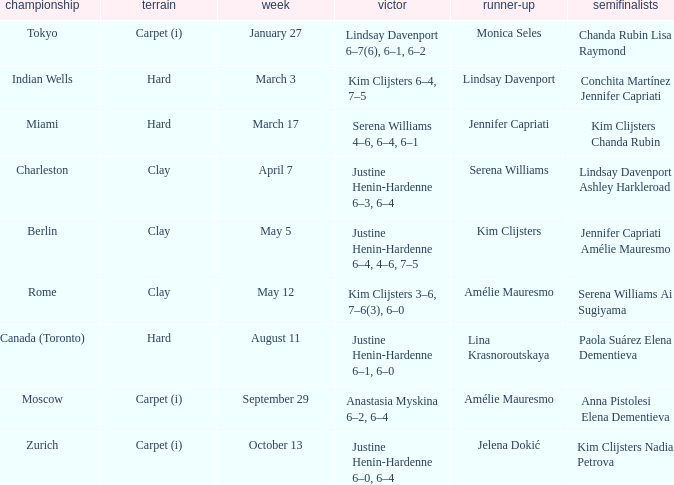Who was the finalist in Miami? Jennifer Capriati. 